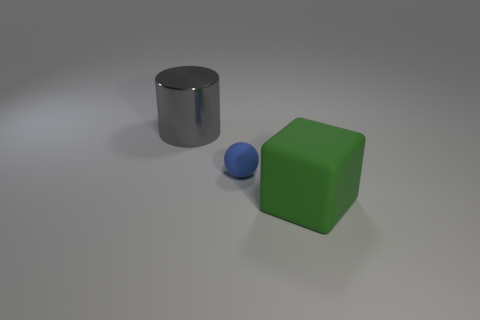Is the thing that is to the right of the small matte sphere made of the same material as the large thing left of the rubber cube?
Ensure brevity in your answer.  No. Are there any big cubes to the right of the gray metallic thing?
Make the answer very short. Yes. How many purple objects are small cubes or rubber balls?
Your answer should be compact. 0. Is the material of the big green cube the same as the object left of the small blue matte thing?
Ensure brevity in your answer.  No. What is the large gray object made of?
Provide a short and direct response. Metal. There is a big thing that is behind the rubber thing in front of the matte object that is to the left of the big green object; what is its material?
Provide a succinct answer. Metal. Is the size of the matte thing that is on the left side of the rubber cube the same as the object in front of the tiny blue object?
Your response must be concise. No. How many other things are made of the same material as the big gray cylinder?
Make the answer very short. 0. How many matte objects are gray things or big yellow objects?
Provide a succinct answer. 0. Is the number of tiny blue matte balls less than the number of cyan matte cylinders?
Your response must be concise. No. 